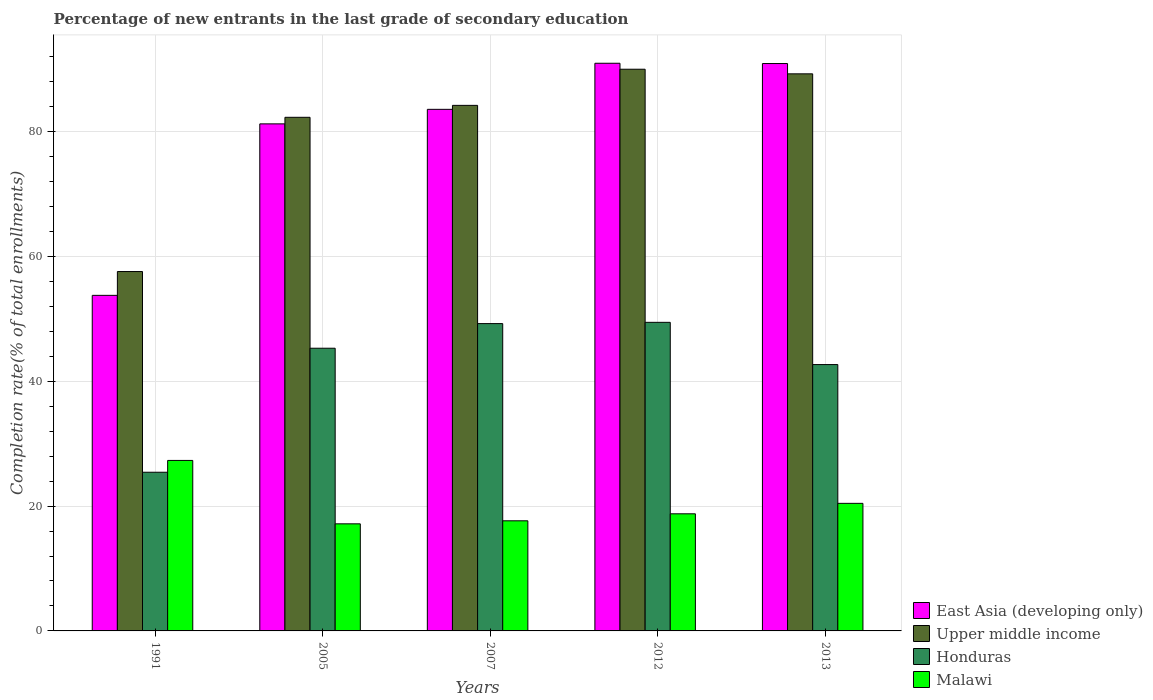Are the number of bars per tick equal to the number of legend labels?
Your answer should be compact. Yes. Are the number of bars on each tick of the X-axis equal?
Offer a very short reply. Yes. How many bars are there on the 3rd tick from the left?
Your answer should be compact. 4. What is the label of the 2nd group of bars from the left?
Your answer should be compact. 2005. In how many cases, is the number of bars for a given year not equal to the number of legend labels?
Make the answer very short. 0. What is the percentage of new entrants in Honduras in 2013?
Offer a very short reply. 42.68. Across all years, what is the maximum percentage of new entrants in East Asia (developing only)?
Your answer should be compact. 90.96. Across all years, what is the minimum percentage of new entrants in Honduras?
Ensure brevity in your answer.  25.43. What is the total percentage of new entrants in Malawi in the graph?
Provide a short and direct response. 101.33. What is the difference between the percentage of new entrants in Malawi in 2007 and that in 2013?
Offer a terse response. -2.8. What is the difference between the percentage of new entrants in Upper middle income in 1991 and the percentage of new entrants in Malawi in 2013?
Offer a terse response. 37.14. What is the average percentage of new entrants in East Asia (developing only) per year?
Your response must be concise. 80.09. In the year 2012, what is the difference between the percentage of new entrants in Malawi and percentage of new entrants in Honduras?
Your answer should be compact. -30.68. What is the ratio of the percentage of new entrants in Upper middle income in 2005 to that in 2013?
Your response must be concise. 0.92. Is the difference between the percentage of new entrants in Malawi in 1991 and 2005 greater than the difference between the percentage of new entrants in Honduras in 1991 and 2005?
Give a very brief answer. Yes. What is the difference between the highest and the second highest percentage of new entrants in Honduras?
Provide a succinct answer. 0.2. What is the difference between the highest and the lowest percentage of new entrants in Upper middle income?
Provide a short and direct response. 32.42. Is the sum of the percentage of new entrants in Upper middle income in 1991 and 2007 greater than the maximum percentage of new entrants in Honduras across all years?
Make the answer very short. Yes. Is it the case that in every year, the sum of the percentage of new entrants in East Asia (developing only) and percentage of new entrants in Upper middle income is greater than the sum of percentage of new entrants in Malawi and percentage of new entrants in Honduras?
Provide a succinct answer. Yes. What does the 4th bar from the left in 2013 represents?
Offer a terse response. Malawi. What does the 2nd bar from the right in 2013 represents?
Your response must be concise. Honduras. Is it the case that in every year, the sum of the percentage of new entrants in Upper middle income and percentage of new entrants in East Asia (developing only) is greater than the percentage of new entrants in Honduras?
Your answer should be very brief. Yes. How many bars are there?
Offer a terse response. 20. Are all the bars in the graph horizontal?
Offer a terse response. No. What is the difference between two consecutive major ticks on the Y-axis?
Your response must be concise. 20. Does the graph contain grids?
Offer a terse response. Yes. What is the title of the graph?
Ensure brevity in your answer.  Percentage of new entrants in the last grade of secondary education. What is the label or title of the X-axis?
Offer a very short reply. Years. What is the label or title of the Y-axis?
Offer a very short reply. Completion rate(% of total enrollments). What is the Completion rate(% of total enrollments) of East Asia (developing only) in 1991?
Ensure brevity in your answer.  53.77. What is the Completion rate(% of total enrollments) in Upper middle income in 1991?
Give a very brief answer. 57.58. What is the Completion rate(% of total enrollments) of Honduras in 1991?
Your response must be concise. 25.43. What is the Completion rate(% of total enrollments) in Malawi in 1991?
Provide a short and direct response. 27.32. What is the Completion rate(% of total enrollments) of East Asia (developing only) in 2005?
Offer a very short reply. 81.25. What is the Completion rate(% of total enrollments) of Upper middle income in 2005?
Provide a succinct answer. 82.3. What is the Completion rate(% of total enrollments) in Honduras in 2005?
Give a very brief answer. 45.3. What is the Completion rate(% of total enrollments) of Malawi in 2005?
Your answer should be compact. 17.16. What is the Completion rate(% of total enrollments) in East Asia (developing only) in 2007?
Offer a very short reply. 83.58. What is the Completion rate(% of total enrollments) in Upper middle income in 2007?
Your answer should be very brief. 84.21. What is the Completion rate(% of total enrollments) in Honduras in 2007?
Keep it short and to the point. 49.24. What is the Completion rate(% of total enrollments) of Malawi in 2007?
Your answer should be very brief. 17.64. What is the Completion rate(% of total enrollments) in East Asia (developing only) in 2012?
Provide a succinct answer. 90.96. What is the Completion rate(% of total enrollments) of Upper middle income in 2012?
Make the answer very short. 90. What is the Completion rate(% of total enrollments) in Honduras in 2012?
Keep it short and to the point. 49.45. What is the Completion rate(% of total enrollments) of Malawi in 2012?
Ensure brevity in your answer.  18.77. What is the Completion rate(% of total enrollments) in East Asia (developing only) in 2013?
Offer a terse response. 90.91. What is the Completion rate(% of total enrollments) in Upper middle income in 2013?
Keep it short and to the point. 89.26. What is the Completion rate(% of total enrollments) of Honduras in 2013?
Provide a short and direct response. 42.68. What is the Completion rate(% of total enrollments) in Malawi in 2013?
Offer a terse response. 20.44. Across all years, what is the maximum Completion rate(% of total enrollments) of East Asia (developing only)?
Keep it short and to the point. 90.96. Across all years, what is the maximum Completion rate(% of total enrollments) of Upper middle income?
Offer a terse response. 90. Across all years, what is the maximum Completion rate(% of total enrollments) of Honduras?
Ensure brevity in your answer.  49.45. Across all years, what is the maximum Completion rate(% of total enrollments) of Malawi?
Offer a terse response. 27.32. Across all years, what is the minimum Completion rate(% of total enrollments) in East Asia (developing only)?
Ensure brevity in your answer.  53.77. Across all years, what is the minimum Completion rate(% of total enrollments) of Upper middle income?
Keep it short and to the point. 57.58. Across all years, what is the minimum Completion rate(% of total enrollments) of Honduras?
Your response must be concise. 25.43. Across all years, what is the minimum Completion rate(% of total enrollments) in Malawi?
Provide a succinct answer. 17.16. What is the total Completion rate(% of total enrollments) in East Asia (developing only) in the graph?
Keep it short and to the point. 400.47. What is the total Completion rate(% of total enrollments) in Upper middle income in the graph?
Your answer should be compact. 403.36. What is the total Completion rate(% of total enrollments) of Honduras in the graph?
Provide a short and direct response. 212.09. What is the total Completion rate(% of total enrollments) in Malawi in the graph?
Offer a terse response. 101.33. What is the difference between the Completion rate(% of total enrollments) in East Asia (developing only) in 1991 and that in 2005?
Your answer should be compact. -27.48. What is the difference between the Completion rate(% of total enrollments) in Upper middle income in 1991 and that in 2005?
Make the answer very short. -24.71. What is the difference between the Completion rate(% of total enrollments) of Honduras in 1991 and that in 2005?
Offer a very short reply. -19.87. What is the difference between the Completion rate(% of total enrollments) of Malawi in 1991 and that in 2005?
Provide a succinct answer. 10.16. What is the difference between the Completion rate(% of total enrollments) in East Asia (developing only) in 1991 and that in 2007?
Offer a terse response. -29.81. What is the difference between the Completion rate(% of total enrollments) of Upper middle income in 1991 and that in 2007?
Keep it short and to the point. -26.63. What is the difference between the Completion rate(% of total enrollments) of Honduras in 1991 and that in 2007?
Ensure brevity in your answer.  -23.82. What is the difference between the Completion rate(% of total enrollments) of Malawi in 1991 and that in 2007?
Your answer should be compact. 9.68. What is the difference between the Completion rate(% of total enrollments) in East Asia (developing only) in 1991 and that in 2012?
Give a very brief answer. -37.19. What is the difference between the Completion rate(% of total enrollments) of Upper middle income in 1991 and that in 2012?
Offer a very short reply. -32.42. What is the difference between the Completion rate(% of total enrollments) in Honduras in 1991 and that in 2012?
Give a very brief answer. -24.02. What is the difference between the Completion rate(% of total enrollments) in Malawi in 1991 and that in 2012?
Your answer should be compact. 8.55. What is the difference between the Completion rate(% of total enrollments) of East Asia (developing only) in 1991 and that in 2013?
Ensure brevity in your answer.  -37.14. What is the difference between the Completion rate(% of total enrollments) of Upper middle income in 1991 and that in 2013?
Your answer should be compact. -31.68. What is the difference between the Completion rate(% of total enrollments) of Honduras in 1991 and that in 2013?
Offer a very short reply. -17.25. What is the difference between the Completion rate(% of total enrollments) of Malawi in 1991 and that in 2013?
Provide a short and direct response. 6.88. What is the difference between the Completion rate(% of total enrollments) of East Asia (developing only) in 2005 and that in 2007?
Give a very brief answer. -2.33. What is the difference between the Completion rate(% of total enrollments) in Upper middle income in 2005 and that in 2007?
Offer a terse response. -1.91. What is the difference between the Completion rate(% of total enrollments) in Honduras in 2005 and that in 2007?
Give a very brief answer. -3.95. What is the difference between the Completion rate(% of total enrollments) in Malawi in 2005 and that in 2007?
Give a very brief answer. -0.48. What is the difference between the Completion rate(% of total enrollments) in East Asia (developing only) in 2005 and that in 2012?
Offer a terse response. -9.71. What is the difference between the Completion rate(% of total enrollments) in Upper middle income in 2005 and that in 2012?
Your response must be concise. -7.7. What is the difference between the Completion rate(% of total enrollments) in Honduras in 2005 and that in 2012?
Offer a very short reply. -4.15. What is the difference between the Completion rate(% of total enrollments) of Malawi in 2005 and that in 2012?
Provide a succinct answer. -1.61. What is the difference between the Completion rate(% of total enrollments) of East Asia (developing only) in 2005 and that in 2013?
Provide a short and direct response. -9.67. What is the difference between the Completion rate(% of total enrollments) of Upper middle income in 2005 and that in 2013?
Your answer should be compact. -6.97. What is the difference between the Completion rate(% of total enrollments) of Honduras in 2005 and that in 2013?
Provide a short and direct response. 2.62. What is the difference between the Completion rate(% of total enrollments) of Malawi in 2005 and that in 2013?
Your answer should be very brief. -3.28. What is the difference between the Completion rate(% of total enrollments) in East Asia (developing only) in 2007 and that in 2012?
Ensure brevity in your answer.  -7.38. What is the difference between the Completion rate(% of total enrollments) in Upper middle income in 2007 and that in 2012?
Offer a terse response. -5.79. What is the difference between the Completion rate(% of total enrollments) of Honduras in 2007 and that in 2012?
Your answer should be very brief. -0.2. What is the difference between the Completion rate(% of total enrollments) in Malawi in 2007 and that in 2012?
Provide a short and direct response. -1.12. What is the difference between the Completion rate(% of total enrollments) of East Asia (developing only) in 2007 and that in 2013?
Provide a short and direct response. -7.34. What is the difference between the Completion rate(% of total enrollments) of Upper middle income in 2007 and that in 2013?
Your response must be concise. -5.05. What is the difference between the Completion rate(% of total enrollments) in Honduras in 2007 and that in 2013?
Your response must be concise. 6.56. What is the difference between the Completion rate(% of total enrollments) in Malawi in 2007 and that in 2013?
Provide a succinct answer. -2.8. What is the difference between the Completion rate(% of total enrollments) of East Asia (developing only) in 2012 and that in 2013?
Give a very brief answer. 0.05. What is the difference between the Completion rate(% of total enrollments) in Upper middle income in 2012 and that in 2013?
Offer a terse response. 0.74. What is the difference between the Completion rate(% of total enrollments) in Honduras in 2012 and that in 2013?
Provide a succinct answer. 6.77. What is the difference between the Completion rate(% of total enrollments) in Malawi in 2012 and that in 2013?
Your answer should be compact. -1.67. What is the difference between the Completion rate(% of total enrollments) of East Asia (developing only) in 1991 and the Completion rate(% of total enrollments) of Upper middle income in 2005?
Offer a very short reply. -28.53. What is the difference between the Completion rate(% of total enrollments) in East Asia (developing only) in 1991 and the Completion rate(% of total enrollments) in Honduras in 2005?
Provide a short and direct response. 8.47. What is the difference between the Completion rate(% of total enrollments) of East Asia (developing only) in 1991 and the Completion rate(% of total enrollments) of Malawi in 2005?
Provide a short and direct response. 36.61. What is the difference between the Completion rate(% of total enrollments) in Upper middle income in 1991 and the Completion rate(% of total enrollments) in Honduras in 2005?
Your answer should be very brief. 12.29. What is the difference between the Completion rate(% of total enrollments) of Upper middle income in 1991 and the Completion rate(% of total enrollments) of Malawi in 2005?
Ensure brevity in your answer.  40.42. What is the difference between the Completion rate(% of total enrollments) of Honduras in 1991 and the Completion rate(% of total enrollments) of Malawi in 2005?
Offer a terse response. 8.27. What is the difference between the Completion rate(% of total enrollments) of East Asia (developing only) in 1991 and the Completion rate(% of total enrollments) of Upper middle income in 2007?
Your answer should be compact. -30.44. What is the difference between the Completion rate(% of total enrollments) of East Asia (developing only) in 1991 and the Completion rate(% of total enrollments) of Honduras in 2007?
Offer a very short reply. 4.53. What is the difference between the Completion rate(% of total enrollments) in East Asia (developing only) in 1991 and the Completion rate(% of total enrollments) in Malawi in 2007?
Your response must be concise. 36.13. What is the difference between the Completion rate(% of total enrollments) in Upper middle income in 1991 and the Completion rate(% of total enrollments) in Honduras in 2007?
Keep it short and to the point. 8.34. What is the difference between the Completion rate(% of total enrollments) of Upper middle income in 1991 and the Completion rate(% of total enrollments) of Malawi in 2007?
Provide a short and direct response. 39.94. What is the difference between the Completion rate(% of total enrollments) in Honduras in 1991 and the Completion rate(% of total enrollments) in Malawi in 2007?
Your response must be concise. 7.78. What is the difference between the Completion rate(% of total enrollments) in East Asia (developing only) in 1991 and the Completion rate(% of total enrollments) in Upper middle income in 2012?
Provide a succinct answer. -36.23. What is the difference between the Completion rate(% of total enrollments) of East Asia (developing only) in 1991 and the Completion rate(% of total enrollments) of Honduras in 2012?
Your answer should be compact. 4.32. What is the difference between the Completion rate(% of total enrollments) in East Asia (developing only) in 1991 and the Completion rate(% of total enrollments) in Malawi in 2012?
Your answer should be compact. 35. What is the difference between the Completion rate(% of total enrollments) of Upper middle income in 1991 and the Completion rate(% of total enrollments) of Honduras in 2012?
Provide a succinct answer. 8.14. What is the difference between the Completion rate(% of total enrollments) in Upper middle income in 1991 and the Completion rate(% of total enrollments) in Malawi in 2012?
Provide a succinct answer. 38.82. What is the difference between the Completion rate(% of total enrollments) of Honduras in 1991 and the Completion rate(% of total enrollments) of Malawi in 2012?
Provide a short and direct response. 6.66. What is the difference between the Completion rate(% of total enrollments) of East Asia (developing only) in 1991 and the Completion rate(% of total enrollments) of Upper middle income in 2013?
Keep it short and to the point. -35.49. What is the difference between the Completion rate(% of total enrollments) in East Asia (developing only) in 1991 and the Completion rate(% of total enrollments) in Honduras in 2013?
Your response must be concise. 11.09. What is the difference between the Completion rate(% of total enrollments) in East Asia (developing only) in 1991 and the Completion rate(% of total enrollments) in Malawi in 2013?
Provide a short and direct response. 33.33. What is the difference between the Completion rate(% of total enrollments) of Upper middle income in 1991 and the Completion rate(% of total enrollments) of Honduras in 2013?
Ensure brevity in your answer.  14.9. What is the difference between the Completion rate(% of total enrollments) in Upper middle income in 1991 and the Completion rate(% of total enrollments) in Malawi in 2013?
Offer a terse response. 37.14. What is the difference between the Completion rate(% of total enrollments) in Honduras in 1991 and the Completion rate(% of total enrollments) in Malawi in 2013?
Your answer should be compact. 4.99. What is the difference between the Completion rate(% of total enrollments) in East Asia (developing only) in 2005 and the Completion rate(% of total enrollments) in Upper middle income in 2007?
Offer a terse response. -2.97. What is the difference between the Completion rate(% of total enrollments) in East Asia (developing only) in 2005 and the Completion rate(% of total enrollments) in Honduras in 2007?
Your answer should be compact. 32. What is the difference between the Completion rate(% of total enrollments) in East Asia (developing only) in 2005 and the Completion rate(% of total enrollments) in Malawi in 2007?
Ensure brevity in your answer.  63.6. What is the difference between the Completion rate(% of total enrollments) of Upper middle income in 2005 and the Completion rate(% of total enrollments) of Honduras in 2007?
Offer a very short reply. 33.05. What is the difference between the Completion rate(% of total enrollments) in Upper middle income in 2005 and the Completion rate(% of total enrollments) in Malawi in 2007?
Your answer should be compact. 64.66. What is the difference between the Completion rate(% of total enrollments) of Honduras in 2005 and the Completion rate(% of total enrollments) of Malawi in 2007?
Your answer should be compact. 27.65. What is the difference between the Completion rate(% of total enrollments) in East Asia (developing only) in 2005 and the Completion rate(% of total enrollments) in Upper middle income in 2012?
Offer a terse response. -8.76. What is the difference between the Completion rate(% of total enrollments) of East Asia (developing only) in 2005 and the Completion rate(% of total enrollments) of Honduras in 2012?
Give a very brief answer. 31.8. What is the difference between the Completion rate(% of total enrollments) in East Asia (developing only) in 2005 and the Completion rate(% of total enrollments) in Malawi in 2012?
Keep it short and to the point. 62.48. What is the difference between the Completion rate(% of total enrollments) of Upper middle income in 2005 and the Completion rate(% of total enrollments) of Honduras in 2012?
Provide a short and direct response. 32.85. What is the difference between the Completion rate(% of total enrollments) in Upper middle income in 2005 and the Completion rate(% of total enrollments) in Malawi in 2012?
Provide a succinct answer. 63.53. What is the difference between the Completion rate(% of total enrollments) of Honduras in 2005 and the Completion rate(% of total enrollments) of Malawi in 2012?
Offer a terse response. 26.53. What is the difference between the Completion rate(% of total enrollments) in East Asia (developing only) in 2005 and the Completion rate(% of total enrollments) in Upper middle income in 2013?
Give a very brief answer. -8.02. What is the difference between the Completion rate(% of total enrollments) in East Asia (developing only) in 2005 and the Completion rate(% of total enrollments) in Honduras in 2013?
Make the answer very short. 38.57. What is the difference between the Completion rate(% of total enrollments) in East Asia (developing only) in 2005 and the Completion rate(% of total enrollments) in Malawi in 2013?
Your answer should be very brief. 60.81. What is the difference between the Completion rate(% of total enrollments) in Upper middle income in 2005 and the Completion rate(% of total enrollments) in Honduras in 2013?
Offer a very short reply. 39.62. What is the difference between the Completion rate(% of total enrollments) in Upper middle income in 2005 and the Completion rate(% of total enrollments) in Malawi in 2013?
Provide a short and direct response. 61.86. What is the difference between the Completion rate(% of total enrollments) in Honduras in 2005 and the Completion rate(% of total enrollments) in Malawi in 2013?
Make the answer very short. 24.86. What is the difference between the Completion rate(% of total enrollments) in East Asia (developing only) in 2007 and the Completion rate(% of total enrollments) in Upper middle income in 2012?
Your answer should be compact. -6.43. What is the difference between the Completion rate(% of total enrollments) of East Asia (developing only) in 2007 and the Completion rate(% of total enrollments) of Honduras in 2012?
Your response must be concise. 34.13. What is the difference between the Completion rate(% of total enrollments) in East Asia (developing only) in 2007 and the Completion rate(% of total enrollments) in Malawi in 2012?
Your answer should be very brief. 64.81. What is the difference between the Completion rate(% of total enrollments) in Upper middle income in 2007 and the Completion rate(% of total enrollments) in Honduras in 2012?
Provide a short and direct response. 34.77. What is the difference between the Completion rate(% of total enrollments) in Upper middle income in 2007 and the Completion rate(% of total enrollments) in Malawi in 2012?
Ensure brevity in your answer.  65.45. What is the difference between the Completion rate(% of total enrollments) in Honduras in 2007 and the Completion rate(% of total enrollments) in Malawi in 2012?
Make the answer very short. 30.48. What is the difference between the Completion rate(% of total enrollments) of East Asia (developing only) in 2007 and the Completion rate(% of total enrollments) of Upper middle income in 2013?
Make the answer very short. -5.69. What is the difference between the Completion rate(% of total enrollments) of East Asia (developing only) in 2007 and the Completion rate(% of total enrollments) of Honduras in 2013?
Your answer should be compact. 40.9. What is the difference between the Completion rate(% of total enrollments) in East Asia (developing only) in 2007 and the Completion rate(% of total enrollments) in Malawi in 2013?
Your response must be concise. 63.14. What is the difference between the Completion rate(% of total enrollments) of Upper middle income in 2007 and the Completion rate(% of total enrollments) of Honduras in 2013?
Ensure brevity in your answer.  41.53. What is the difference between the Completion rate(% of total enrollments) of Upper middle income in 2007 and the Completion rate(% of total enrollments) of Malawi in 2013?
Provide a short and direct response. 63.77. What is the difference between the Completion rate(% of total enrollments) in Honduras in 2007 and the Completion rate(% of total enrollments) in Malawi in 2013?
Give a very brief answer. 28.8. What is the difference between the Completion rate(% of total enrollments) in East Asia (developing only) in 2012 and the Completion rate(% of total enrollments) in Upper middle income in 2013?
Keep it short and to the point. 1.7. What is the difference between the Completion rate(% of total enrollments) of East Asia (developing only) in 2012 and the Completion rate(% of total enrollments) of Honduras in 2013?
Your answer should be very brief. 48.28. What is the difference between the Completion rate(% of total enrollments) of East Asia (developing only) in 2012 and the Completion rate(% of total enrollments) of Malawi in 2013?
Ensure brevity in your answer.  70.52. What is the difference between the Completion rate(% of total enrollments) in Upper middle income in 2012 and the Completion rate(% of total enrollments) in Honduras in 2013?
Your answer should be very brief. 47.32. What is the difference between the Completion rate(% of total enrollments) in Upper middle income in 2012 and the Completion rate(% of total enrollments) in Malawi in 2013?
Provide a short and direct response. 69.56. What is the difference between the Completion rate(% of total enrollments) in Honduras in 2012 and the Completion rate(% of total enrollments) in Malawi in 2013?
Your response must be concise. 29. What is the average Completion rate(% of total enrollments) of East Asia (developing only) per year?
Keep it short and to the point. 80.09. What is the average Completion rate(% of total enrollments) of Upper middle income per year?
Your response must be concise. 80.67. What is the average Completion rate(% of total enrollments) of Honduras per year?
Give a very brief answer. 42.42. What is the average Completion rate(% of total enrollments) in Malawi per year?
Give a very brief answer. 20.27. In the year 1991, what is the difference between the Completion rate(% of total enrollments) of East Asia (developing only) and Completion rate(% of total enrollments) of Upper middle income?
Offer a terse response. -3.81. In the year 1991, what is the difference between the Completion rate(% of total enrollments) of East Asia (developing only) and Completion rate(% of total enrollments) of Honduras?
Your answer should be very brief. 28.34. In the year 1991, what is the difference between the Completion rate(% of total enrollments) of East Asia (developing only) and Completion rate(% of total enrollments) of Malawi?
Your answer should be very brief. 26.45. In the year 1991, what is the difference between the Completion rate(% of total enrollments) in Upper middle income and Completion rate(% of total enrollments) in Honduras?
Your answer should be compact. 32.16. In the year 1991, what is the difference between the Completion rate(% of total enrollments) of Upper middle income and Completion rate(% of total enrollments) of Malawi?
Keep it short and to the point. 30.27. In the year 1991, what is the difference between the Completion rate(% of total enrollments) of Honduras and Completion rate(% of total enrollments) of Malawi?
Provide a succinct answer. -1.89. In the year 2005, what is the difference between the Completion rate(% of total enrollments) in East Asia (developing only) and Completion rate(% of total enrollments) in Upper middle income?
Keep it short and to the point. -1.05. In the year 2005, what is the difference between the Completion rate(% of total enrollments) in East Asia (developing only) and Completion rate(% of total enrollments) in Honduras?
Your answer should be very brief. 35.95. In the year 2005, what is the difference between the Completion rate(% of total enrollments) in East Asia (developing only) and Completion rate(% of total enrollments) in Malawi?
Your answer should be compact. 64.09. In the year 2005, what is the difference between the Completion rate(% of total enrollments) of Upper middle income and Completion rate(% of total enrollments) of Honduras?
Provide a short and direct response. 37. In the year 2005, what is the difference between the Completion rate(% of total enrollments) of Upper middle income and Completion rate(% of total enrollments) of Malawi?
Your answer should be very brief. 65.14. In the year 2005, what is the difference between the Completion rate(% of total enrollments) in Honduras and Completion rate(% of total enrollments) in Malawi?
Your answer should be compact. 28.14. In the year 2007, what is the difference between the Completion rate(% of total enrollments) of East Asia (developing only) and Completion rate(% of total enrollments) of Upper middle income?
Keep it short and to the point. -0.64. In the year 2007, what is the difference between the Completion rate(% of total enrollments) of East Asia (developing only) and Completion rate(% of total enrollments) of Honduras?
Keep it short and to the point. 34.33. In the year 2007, what is the difference between the Completion rate(% of total enrollments) in East Asia (developing only) and Completion rate(% of total enrollments) in Malawi?
Make the answer very short. 65.93. In the year 2007, what is the difference between the Completion rate(% of total enrollments) in Upper middle income and Completion rate(% of total enrollments) in Honduras?
Your answer should be very brief. 34.97. In the year 2007, what is the difference between the Completion rate(% of total enrollments) of Upper middle income and Completion rate(% of total enrollments) of Malawi?
Offer a terse response. 66.57. In the year 2007, what is the difference between the Completion rate(% of total enrollments) of Honduras and Completion rate(% of total enrollments) of Malawi?
Give a very brief answer. 31.6. In the year 2012, what is the difference between the Completion rate(% of total enrollments) of East Asia (developing only) and Completion rate(% of total enrollments) of Upper middle income?
Make the answer very short. 0.96. In the year 2012, what is the difference between the Completion rate(% of total enrollments) of East Asia (developing only) and Completion rate(% of total enrollments) of Honduras?
Keep it short and to the point. 41.51. In the year 2012, what is the difference between the Completion rate(% of total enrollments) in East Asia (developing only) and Completion rate(% of total enrollments) in Malawi?
Offer a terse response. 72.19. In the year 2012, what is the difference between the Completion rate(% of total enrollments) in Upper middle income and Completion rate(% of total enrollments) in Honduras?
Your answer should be compact. 40.56. In the year 2012, what is the difference between the Completion rate(% of total enrollments) of Upper middle income and Completion rate(% of total enrollments) of Malawi?
Ensure brevity in your answer.  71.24. In the year 2012, what is the difference between the Completion rate(% of total enrollments) in Honduras and Completion rate(% of total enrollments) in Malawi?
Provide a succinct answer. 30.68. In the year 2013, what is the difference between the Completion rate(% of total enrollments) in East Asia (developing only) and Completion rate(% of total enrollments) in Upper middle income?
Offer a very short reply. 1.65. In the year 2013, what is the difference between the Completion rate(% of total enrollments) in East Asia (developing only) and Completion rate(% of total enrollments) in Honduras?
Your answer should be compact. 48.23. In the year 2013, what is the difference between the Completion rate(% of total enrollments) of East Asia (developing only) and Completion rate(% of total enrollments) of Malawi?
Ensure brevity in your answer.  70.47. In the year 2013, what is the difference between the Completion rate(% of total enrollments) in Upper middle income and Completion rate(% of total enrollments) in Honduras?
Provide a short and direct response. 46.58. In the year 2013, what is the difference between the Completion rate(% of total enrollments) of Upper middle income and Completion rate(% of total enrollments) of Malawi?
Provide a succinct answer. 68.82. In the year 2013, what is the difference between the Completion rate(% of total enrollments) of Honduras and Completion rate(% of total enrollments) of Malawi?
Provide a succinct answer. 22.24. What is the ratio of the Completion rate(% of total enrollments) in East Asia (developing only) in 1991 to that in 2005?
Offer a very short reply. 0.66. What is the ratio of the Completion rate(% of total enrollments) in Upper middle income in 1991 to that in 2005?
Give a very brief answer. 0.7. What is the ratio of the Completion rate(% of total enrollments) of Honduras in 1991 to that in 2005?
Ensure brevity in your answer.  0.56. What is the ratio of the Completion rate(% of total enrollments) of Malawi in 1991 to that in 2005?
Your answer should be very brief. 1.59. What is the ratio of the Completion rate(% of total enrollments) of East Asia (developing only) in 1991 to that in 2007?
Offer a very short reply. 0.64. What is the ratio of the Completion rate(% of total enrollments) in Upper middle income in 1991 to that in 2007?
Keep it short and to the point. 0.68. What is the ratio of the Completion rate(% of total enrollments) in Honduras in 1991 to that in 2007?
Provide a short and direct response. 0.52. What is the ratio of the Completion rate(% of total enrollments) of Malawi in 1991 to that in 2007?
Provide a succinct answer. 1.55. What is the ratio of the Completion rate(% of total enrollments) of East Asia (developing only) in 1991 to that in 2012?
Offer a terse response. 0.59. What is the ratio of the Completion rate(% of total enrollments) of Upper middle income in 1991 to that in 2012?
Provide a succinct answer. 0.64. What is the ratio of the Completion rate(% of total enrollments) in Honduras in 1991 to that in 2012?
Ensure brevity in your answer.  0.51. What is the ratio of the Completion rate(% of total enrollments) in Malawi in 1991 to that in 2012?
Give a very brief answer. 1.46. What is the ratio of the Completion rate(% of total enrollments) in East Asia (developing only) in 1991 to that in 2013?
Your answer should be very brief. 0.59. What is the ratio of the Completion rate(% of total enrollments) of Upper middle income in 1991 to that in 2013?
Offer a very short reply. 0.65. What is the ratio of the Completion rate(% of total enrollments) of Honduras in 1991 to that in 2013?
Provide a short and direct response. 0.6. What is the ratio of the Completion rate(% of total enrollments) in Malawi in 1991 to that in 2013?
Your answer should be compact. 1.34. What is the ratio of the Completion rate(% of total enrollments) of East Asia (developing only) in 2005 to that in 2007?
Ensure brevity in your answer.  0.97. What is the ratio of the Completion rate(% of total enrollments) of Upper middle income in 2005 to that in 2007?
Your response must be concise. 0.98. What is the ratio of the Completion rate(% of total enrollments) of Honduras in 2005 to that in 2007?
Ensure brevity in your answer.  0.92. What is the ratio of the Completion rate(% of total enrollments) in Malawi in 2005 to that in 2007?
Your response must be concise. 0.97. What is the ratio of the Completion rate(% of total enrollments) in East Asia (developing only) in 2005 to that in 2012?
Offer a terse response. 0.89. What is the ratio of the Completion rate(% of total enrollments) in Upper middle income in 2005 to that in 2012?
Offer a very short reply. 0.91. What is the ratio of the Completion rate(% of total enrollments) in Honduras in 2005 to that in 2012?
Make the answer very short. 0.92. What is the ratio of the Completion rate(% of total enrollments) in Malawi in 2005 to that in 2012?
Your answer should be compact. 0.91. What is the ratio of the Completion rate(% of total enrollments) of East Asia (developing only) in 2005 to that in 2013?
Provide a succinct answer. 0.89. What is the ratio of the Completion rate(% of total enrollments) of Upper middle income in 2005 to that in 2013?
Provide a short and direct response. 0.92. What is the ratio of the Completion rate(% of total enrollments) of Honduras in 2005 to that in 2013?
Give a very brief answer. 1.06. What is the ratio of the Completion rate(% of total enrollments) of Malawi in 2005 to that in 2013?
Offer a terse response. 0.84. What is the ratio of the Completion rate(% of total enrollments) in East Asia (developing only) in 2007 to that in 2012?
Your answer should be very brief. 0.92. What is the ratio of the Completion rate(% of total enrollments) in Upper middle income in 2007 to that in 2012?
Offer a very short reply. 0.94. What is the ratio of the Completion rate(% of total enrollments) in Honduras in 2007 to that in 2012?
Ensure brevity in your answer.  1. What is the ratio of the Completion rate(% of total enrollments) in Malawi in 2007 to that in 2012?
Your answer should be compact. 0.94. What is the ratio of the Completion rate(% of total enrollments) of East Asia (developing only) in 2007 to that in 2013?
Provide a short and direct response. 0.92. What is the ratio of the Completion rate(% of total enrollments) in Upper middle income in 2007 to that in 2013?
Your answer should be compact. 0.94. What is the ratio of the Completion rate(% of total enrollments) of Honduras in 2007 to that in 2013?
Keep it short and to the point. 1.15. What is the ratio of the Completion rate(% of total enrollments) in Malawi in 2007 to that in 2013?
Give a very brief answer. 0.86. What is the ratio of the Completion rate(% of total enrollments) in Upper middle income in 2012 to that in 2013?
Ensure brevity in your answer.  1.01. What is the ratio of the Completion rate(% of total enrollments) of Honduras in 2012 to that in 2013?
Your response must be concise. 1.16. What is the ratio of the Completion rate(% of total enrollments) of Malawi in 2012 to that in 2013?
Your answer should be compact. 0.92. What is the difference between the highest and the second highest Completion rate(% of total enrollments) of East Asia (developing only)?
Your answer should be compact. 0.05. What is the difference between the highest and the second highest Completion rate(% of total enrollments) of Upper middle income?
Make the answer very short. 0.74. What is the difference between the highest and the second highest Completion rate(% of total enrollments) in Honduras?
Provide a succinct answer. 0.2. What is the difference between the highest and the second highest Completion rate(% of total enrollments) of Malawi?
Offer a very short reply. 6.88. What is the difference between the highest and the lowest Completion rate(% of total enrollments) of East Asia (developing only)?
Provide a short and direct response. 37.19. What is the difference between the highest and the lowest Completion rate(% of total enrollments) in Upper middle income?
Make the answer very short. 32.42. What is the difference between the highest and the lowest Completion rate(% of total enrollments) in Honduras?
Provide a short and direct response. 24.02. What is the difference between the highest and the lowest Completion rate(% of total enrollments) of Malawi?
Offer a terse response. 10.16. 